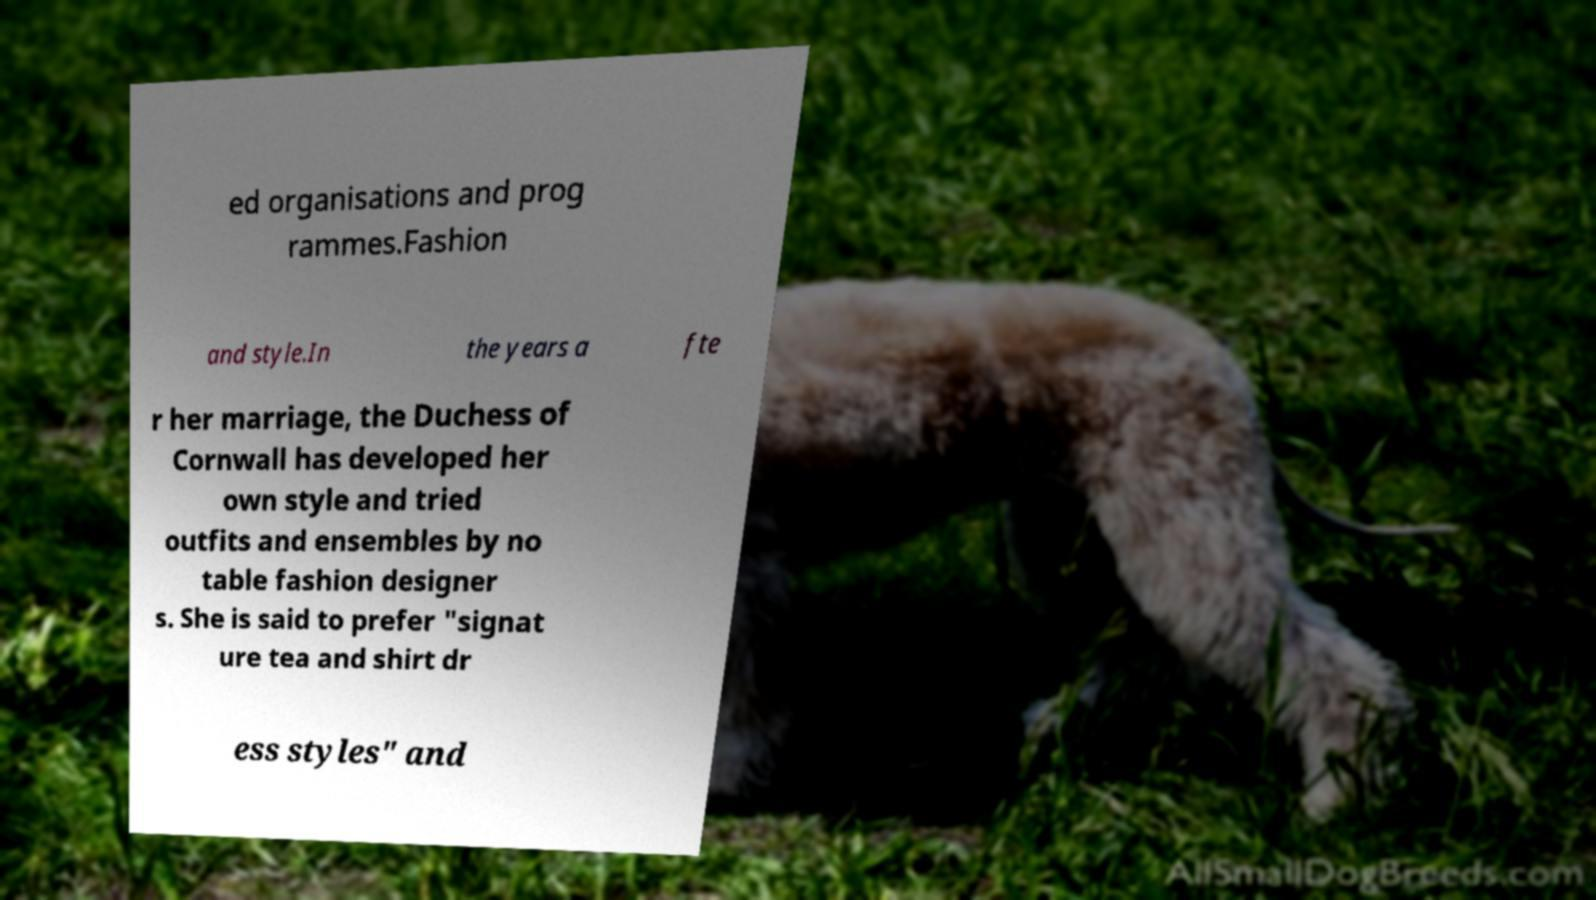Please read and relay the text visible in this image. What does it say? ed organisations and prog rammes.Fashion and style.In the years a fte r her marriage, the Duchess of Cornwall has developed her own style and tried outfits and ensembles by no table fashion designer s. She is said to prefer "signat ure tea and shirt dr ess styles" and 